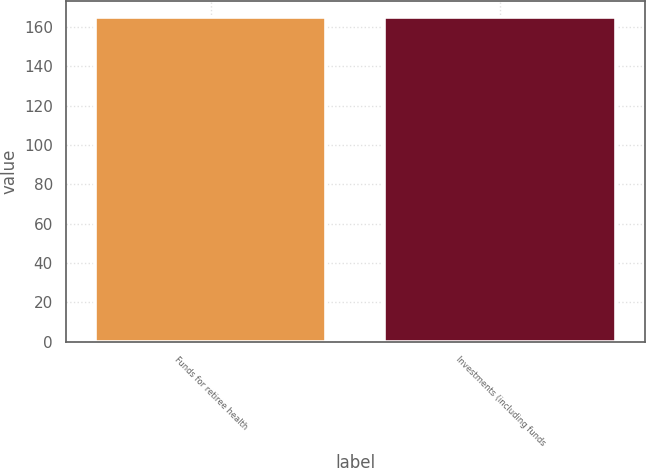Convert chart. <chart><loc_0><loc_0><loc_500><loc_500><bar_chart><fcel>Funds for retiree health<fcel>Investments (including funds<nl><fcel>165<fcel>165.1<nl></chart> 